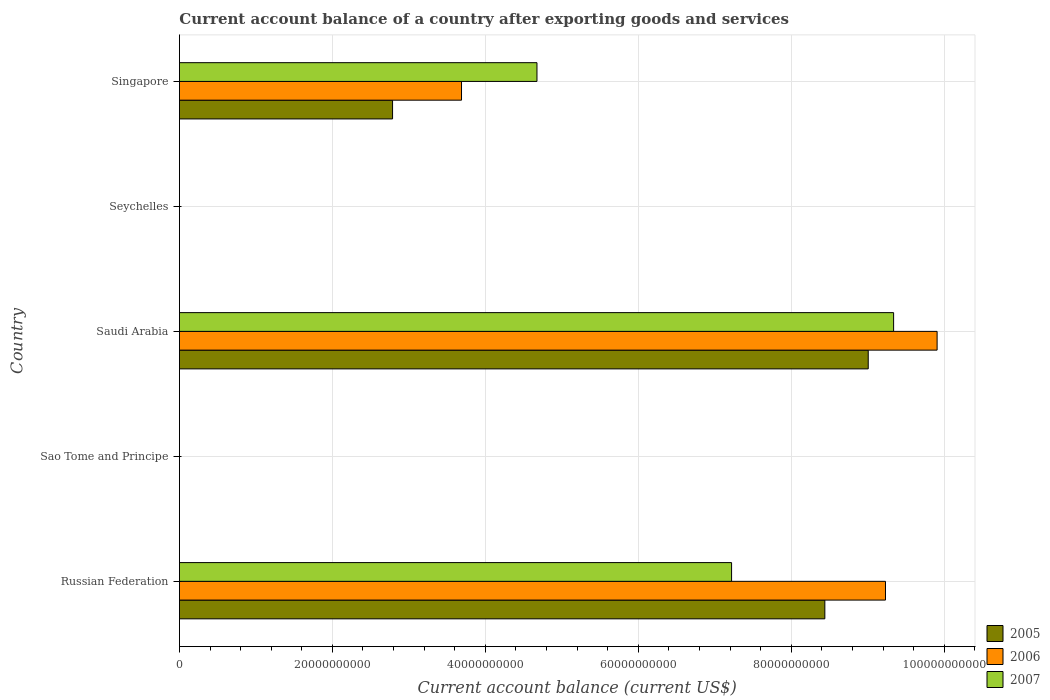Are the number of bars per tick equal to the number of legend labels?
Ensure brevity in your answer.  No. Are the number of bars on each tick of the Y-axis equal?
Your response must be concise. No. What is the label of the 3rd group of bars from the top?
Ensure brevity in your answer.  Saudi Arabia. What is the account balance in 2006 in Russian Federation?
Provide a short and direct response. 9.23e+1. Across all countries, what is the maximum account balance in 2007?
Offer a very short reply. 9.34e+1. In which country was the account balance in 2007 maximum?
Make the answer very short. Saudi Arabia. What is the total account balance in 2006 in the graph?
Provide a succinct answer. 2.28e+11. What is the difference between the account balance in 2007 in Russian Federation and that in Singapore?
Your answer should be very brief. 2.54e+1. What is the difference between the account balance in 2006 in Russian Federation and the account balance in 2005 in Seychelles?
Your response must be concise. 9.23e+1. What is the average account balance in 2007 per country?
Your answer should be compact. 4.25e+1. What is the difference between the account balance in 2007 and account balance in 2005 in Saudi Arabia?
Provide a succinct answer. 3.32e+09. What is the ratio of the account balance in 2006 in Saudi Arabia to that in Singapore?
Provide a short and direct response. 2.69. What is the difference between the highest and the second highest account balance in 2005?
Ensure brevity in your answer.  5.67e+09. What is the difference between the highest and the lowest account balance in 2005?
Offer a terse response. 9.01e+1. In how many countries, is the account balance in 2005 greater than the average account balance in 2005 taken over all countries?
Your response must be concise. 2. How many bars are there?
Your answer should be very brief. 9. How many countries are there in the graph?
Offer a very short reply. 5. What is the difference between two consecutive major ticks on the X-axis?
Provide a short and direct response. 2.00e+1. Are the values on the major ticks of X-axis written in scientific E-notation?
Your answer should be compact. No. Does the graph contain grids?
Keep it short and to the point. Yes. How many legend labels are there?
Give a very brief answer. 3. What is the title of the graph?
Your answer should be very brief. Current account balance of a country after exporting goods and services. What is the label or title of the X-axis?
Provide a succinct answer. Current account balance (current US$). What is the Current account balance (current US$) of 2005 in Russian Federation?
Give a very brief answer. 8.44e+1. What is the Current account balance (current US$) in 2006 in Russian Federation?
Offer a very short reply. 9.23e+1. What is the Current account balance (current US$) of 2007 in Russian Federation?
Give a very brief answer. 7.22e+1. What is the Current account balance (current US$) in 2005 in Sao Tome and Principe?
Offer a very short reply. 0. What is the Current account balance (current US$) in 2006 in Sao Tome and Principe?
Your response must be concise. 0. What is the Current account balance (current US$) of 2007 in Sao Tome and Principe?
Your answer should be compact. 0. What is the Current account balance (current US$) in 2005 in Saudi Arabia?
Ensure brevity in your answer.  9.01e+1. What is the Current account balance (current US$) of 2006 in Saudi Arabia?
Provide a short and direct response. 9.91e+1. What is the Current account balance (current US$) of 2007 in Saudi Arabia?
Your answer should be compact. 9.34e+1. What is the Current account balance (current US$) in 2005 in Seychelles?
Provide a short and direct response. 0. What is the Current account balance (current US$) of 2007 in Seychelles?
Provide a short and direct response. 0. What is the Current account balance (current US$) of 2005 in Singapore?
Keep it short and to the point. 2.79e+1. What is the Current account balance (current US$) of 2006 in Singapore?
Your answer should be compact. 3.69e+1. What is the Current account balance (current US$) of 2007 in Singapore?
Offer a terse response. 4.67e+1. Across all countries, what is the maximum Current account balance (current US$) of 2005?
Ensure brevity in your answer.  9.01e+1. Across all countries, what is the maximum Current account balance (current US$) in 2006?
Ensure brevity in your answer.  9.91e+1. Across all countries, what is the maximum Current account balance (current US$) of 2007?
Keep it short and to the point. 9.34e+1. Across all countries, what is the minimum Current account balance (current US$) of 2005?
Give a very brief answer. 0. Across all countries, what is the minimum Current account balance (current US$) in 2007?
Offer a terse response. 0. What is the total Current account balance (current US$) in 2005 in the graph?
Your answer should be very brief. 2.02e+11. What is the total Current account balance (current US$) in 2006 in the graph?
Provide a succinct answer. 2.28e+11. What is the total Current account balance (current US$) in 2007 in the graph?
Provide a short and direct response. 2.12e+11. What is the difference between the Current account balance (current US$) of 2005 in Russian Federation and that in Saudi Arabia?
Provide a succinct answer. -5.67e+09. What is the difference between the Current account balance (current US$) in 2006 in Russian Federation and that in Saudi Arabia?
Make the answer very short. -6.75e+09. What is the difference between the Current account balance (current US$) of 2007 in Russian Federation and that in Saudi Arabia?
Your response must be concise. -2.12e+1. What is the difference between the Current account balance (current US$) in 2005 in Russian Federation and that in Singapore?
Provide a short and direct response. 5.65e+1. What is the difference between the Current account balance (current US$) in 2006 in Russian Federation and that in Singapore?
Give a very brief answer. 5.54e+1. What is the difference between the Current account balance (current US$) in 2007 in Russian Federation and that in Singapore?
Make the answer very short. 2.54e+1. What is the difference between the Current account balance (current US$) in 2005 in Saudi Arabia and that in Singapore?
Your answer should be very brief. 6.22e+1. What is the difference between the Current account balance (current US$) in 2006 in Saudi Arabia and that in Singapore?
Your answer should be very brief. 6.22e+1. What is the difference between the Current account balance (current US$) of 2007 in Saudi Arabia and that in Singapore?
Provide a succinct answer. 4.66e+1. What is the difference between the Current account balance (current US$) of 2005 in Russian Federation and the Current account balance (current US$) of 2006 in Saudi Arabia?
Your answer should be compact. -1.47e+1. What is the difference between the Current account balance (current US$) in 2005 in Russian Federation and the Current account balance (current US$) in 2007 in Saudi Arabia?
Make the answer very short. -8.99e+09. What is the difference between the Current account balance (current US$) of 2006 in Russian Federation and the Current account balance (current US$) of 2007 in Saudi Arabia?
Your response must be concise. -1.06e+09. What is the difference between the Current account balance (current US$) in 2005 in Russian Federation and the Current account balance (current US$) in 2006 in Singapore?
Your response must be concise. 4.75e+1. What is the difference between the Current account balance (current US$) in 2005 in Russian Federation and the Current account balance (current US$) in 2007 in Singapore?
Give a very brief answer. 3.76e+1. What is the difference between the Current account balance (current US$) of 2006 in Russian Federation and the Current account balance (current US$) of 2007 in Singapore?
Your answer should be compact. 4.56e+1. What is the difference between the Current account balance (current US$) in 2005 in Saudi Arabia and the Current account balance (current US$) in 2006 in Singapore?
Offer a very short reply. 5.32e+1. What is the difference between the Current account balance (current US$) in 2005 in Saudi Arabia and the Current account balance (current US$) in 2007 in Singapore?
Keep it short and to the point. 4.33e+1. What is the difference between the Current account balance (current US$) of 2006 in Saudi Arabia and the Current account balance (current US$) of 2007 in Singapore?
Give a very brief answer. 5.23e+1. What is the average Current account balance (current US$) in 2005 per country?
Offer a very short reply. 4.05e+1. What is the average Current account balance (current US$) in 2006 per country?
Keep it short and to the point. 4.57e+1. What is the average Current account balance (current US$) in 2007 per country?
Your answer should be very brief. 4.25e+1. What is the difference between the Current account balance (current US$) in 2005 and Current account balance (current US$) in 2006 in Russian Federation?
Ensure brevity in your answer.  -7.93e+09. What is the difference between the Current account balance (current US$) of 2005 and Current account balance (current US$) of 2007 in Russian Federation?
Your answer should be very brief. 1.22e+1. What is the difference between the Current account balance (current US$) of 2006 and Current account balance (current US$) of 2007 in Russian Federation?
Your answer should be very brief. 2.01e+1. What is the difference between the Current account balance (current US$) in 2005 and Current account balance (current US$) in 2006 in Saudi Arabia?
Your response must be concise. -9.01e+09. What is the difference between the Current account balance (current US$) of 2005 and Current account balance (current US$) of 2007 in Saudi Arabia?
Your answer should be compact. -3.32e+09. What is the difference between the Current account balance (current US$) of 2006 and Current account balance (current US$) of 2007 in Saudi Arabia?
Provide a short and direct response. 5.69e+09. What is the difference between the Current account balance (current US$) of 2005 and Current account balance (current US$) of 2006 in Singapore?
Your answer should be very brief. -9.02e+09. What is the difference between the Current account balance (current US$) of 2005 and Current account balance (current US$) of 2007 in Singapore?
Give a very brief answer. -1.89e+1. What is the difference between the Current account balance (current US$) of 2006 and Current account balance (current US$) of 2007 in Singapore?
Make the answer very short. -9.86e+09. What is the ratio of the Current account balance (current US$) of 2005 in Russian Federation to that in Saudi Arabia?
Your answer should be very brief. 0.94. What is the ratio of the Current account balance (current US$) of 2006 in Russian Federation to that in Saudi Arabia?
Provide a succinct answer. 0.93. What is the ratio of the Current account balance (current US$) in 2007 in Russian Federation to that in Saudi Arabia?
Your answer should be very brief. 0.77. What is the ratio of the Current account balance (current US$) of 2005 in Russian Federation to that in Singapore?
Your answer should be very brief. 3.03. What is the ratio of the Current account balance (current US$) of 2006 in Russian Federation to that in Singapore?
Keep it short and to the point. 2.5. What is the ratio of the Current account balance (current US$) of 2007 in Russian Federation to that in Singapore?
Make the answer very short. 1.54. What is the ratio of the Current account balance (current US$) of 2005 in Saudi Arabia to that in Singapore?
Ensure brevity in your answer.  3.23. What is the ratio of the Current account balance (current US$) of 2006 in Saudi Arabia to that in Singapore?
Your answer should be compact. 2.69. What is the ratio of the Current account balance (current US$) in 2007 in Saudi Arabia to that in Singapore?
Your answer should be compact. 2. What is the difference between the highest and the second highest Current account balance (current US$) in 2005?
Your response must be concise. 5.67e+09. What is the difference between the highest and the second highest Current account balance (current US$) of 2006?
Make the answer very short. 6.75e+09. What is the difference between the highest and the second highest Current account balance (current US$) in 2007?
Make the answer very short. 2.12e+1. What is the difference between the highest and the lowest Current account balance (current US$) in 2005?
Provide a short and direct response. 9.01e+1. What is the difference between the highest and the lowest Current account balance (current US$) of 2006?
Your answer should be compact. 9.91e+1. What is the difference between the highest and the lowest Current account balance (current US$) of 2007?
Your answer should be very brief. 9.34e+1. 